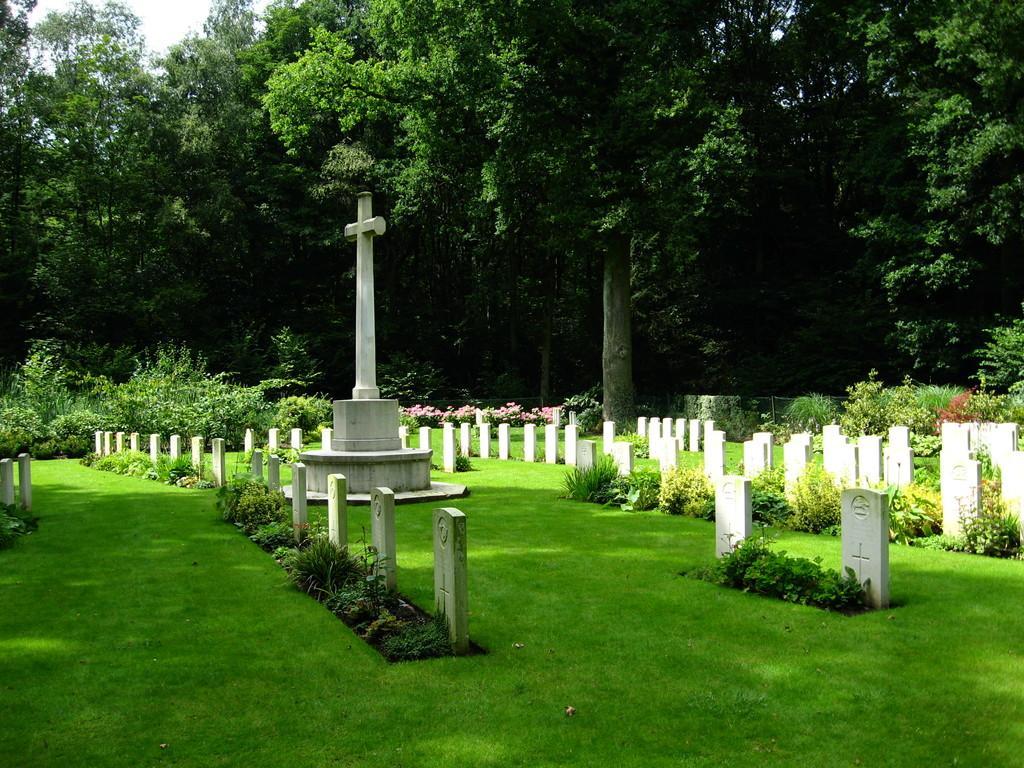Please provide a concise description of this image. This picture is clicked outside. In the foreground we can see the graves and the headstones and we can see the green grass, plants and the sculpture. In the background we can see the sky, trees, flowers, plants and some other objects. 